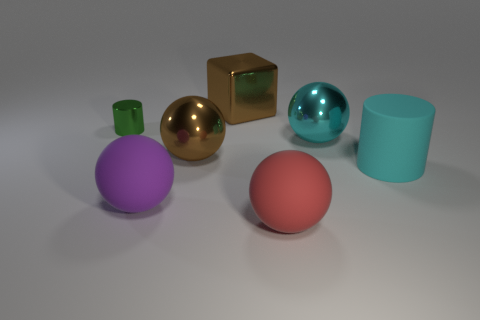Subtract 1 balls. How many balls are left? 3 Subtract all cyan balls. How many balls are left? 3 Add 2 tiny purple metallic cylinders. How many objects exist? 9 Subtract all green balls. Subtract all yellow cylinders. How many balls are left? 4 Subtract all balls. How many objects are left? 3 Subtract all large cylinders. Subtract all brown shiny objects. How many objects are left? 4 Add 3 brown balls. How many brown balls are left? 4 Add 7 metallic blocks. How many metallic blocks exist? 8 Subtract 0 purple cubes. How many objects are left? 7 